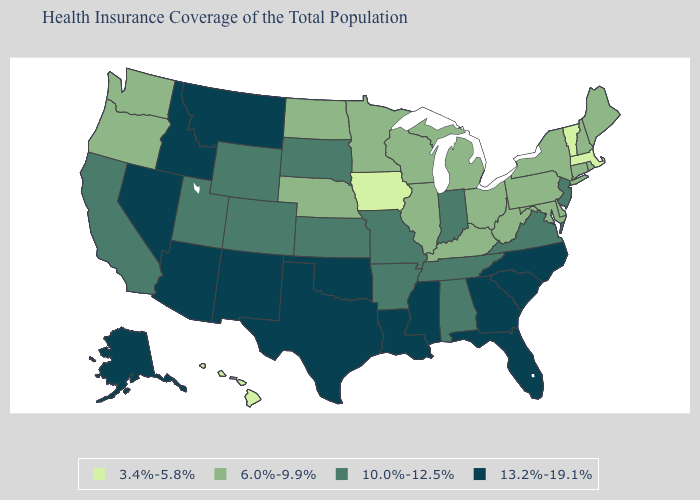Does Washington have the highest value in the West?
Quick response, please. No. Which states have the highest value in the USA?
Write a very short answer. Alaska, Arizona, Florida, Georgia, Idaho, Louisiana, Mississippi, Montana, Nevada, New Mexico, North Carolina, Oklahoma, South Carolina, Texas. Which states have the lowest value in the West?
Keep it brief. Hawaii. Among the states that border Iowa , which have the lowest value?
Keep it brief. Illinois, Minnesota, Nebraska, Wisconsin. Name the states that have a value in the range 6.0%-9.9%?
Keep it brief. Connecticut, Delaware, Illinois, Kentucky, Maine, Maryland, Michigan, Minnesota, Nebraska, New Hampshire, New York, North Dakota, Ohio, Oregon, Pennsylvania, Rhode Island, Washington, West Virginia, Wisconsin. What is the highest value in states that border California?
Keep it brief. 13.2%-19.1%. Name the states that have a value in the range 6.0%-9.9%?
Quick response, please. Connecticut, Delaware, Illinois, Kentucky, Maine, Maryland, Michigan, Minnesota, Nebraska, New Hampshire, New York, North Dakota, Ohio, Oregon, Pennsylvania, Rhode Island, Washington, West Virginia, Wisconsin. Is the legend a continuous bar?
Short answer required. No. Among the states that border Montana , which have the highest value?
Quick response, please. Idaho. Which states hav the highest value in the Northeast?
Be succinct. New Jersey. Does the map have missing data?
Keep it brief. No. Which states have the lowest value in the South?
Concise answer only. Delaware, Kentucky, Maryland, West Virginia. Among the states that border Illinois , does Kentucky have the highest value?
Keep it brief. No. Does New Mexico have the lowest value in the West?
Be succinct. No. Among the states that border Utah , which have the lowest value?
Quick response, please. Colorado, Wyoming. 